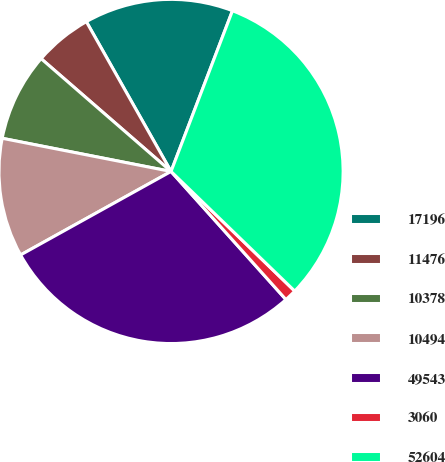Convert chart. <chart><loc_0><loc_0><loc_500><loc_500><pie_chart><fcel>17196<fcel>11476<fcel>10378<fcel>10494<fcel>49543<fcel>3060<fcel>52604<nl><fcel>14.0%<fcel>5.43%<fcel>8.29%<fcel>11.15%<fcel>28.57%<fcel>1.13%<fcel>31.42%<nl></chart> 